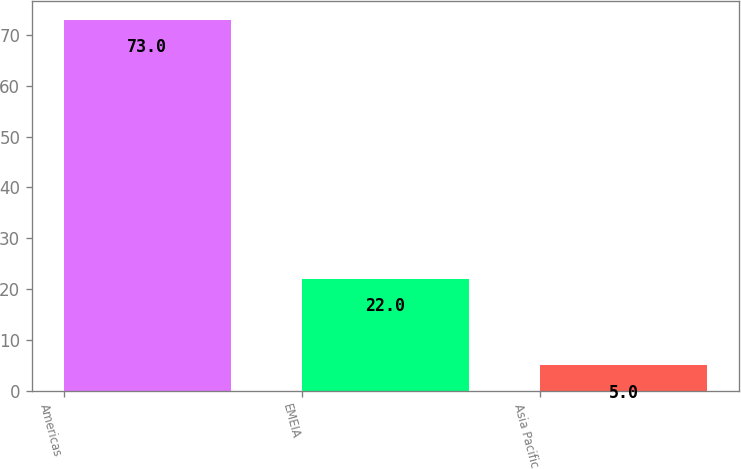Convert chart. <chart><loc_0><loc_0><loc_500><loc_500><bar_chart><fcel>Americas<fcel>EMEIA<fcel>Asia Pacific<nl><fcel>73<fcel>22<fcel>5<nl></chart> 